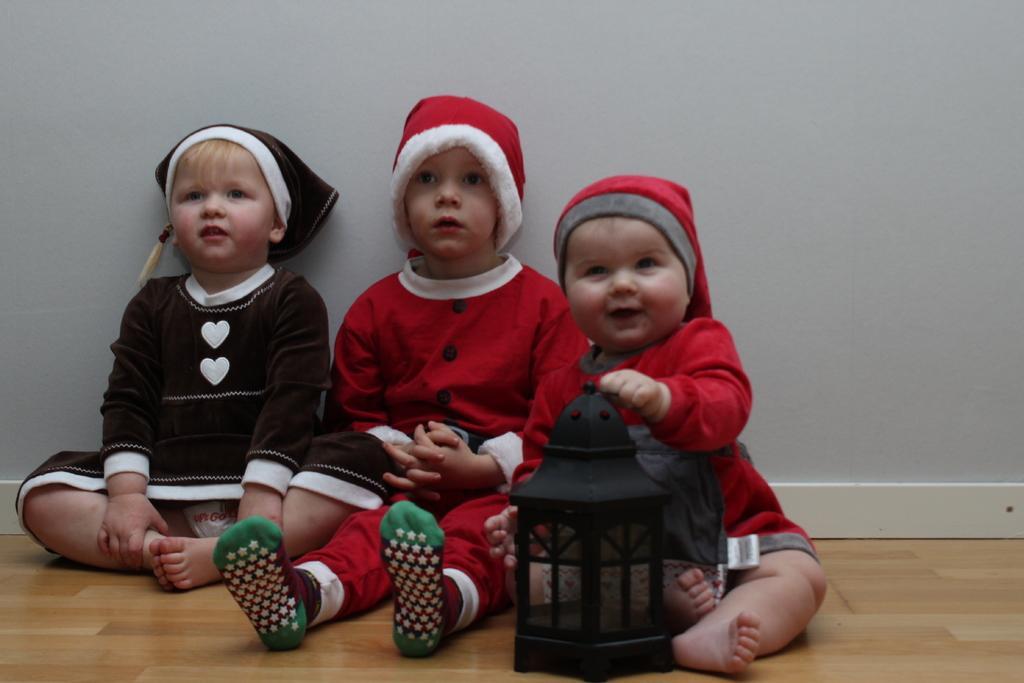In one or two sentences, can you explain what this image depicts? On the floor there are two kids with red dress and red caps on their heads. At the left corner there is a kid. In front of the kid there is a black color item. At the left corner of the image there is a kid with black and white dress and black cap on the head. Behind them there is a white color wall. 